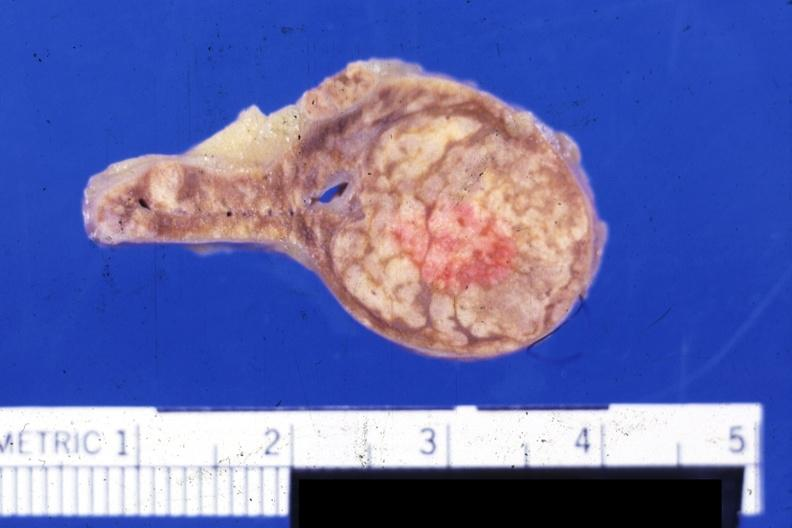s adrenal present?
Answer the question using a single word or phrase. Yes 